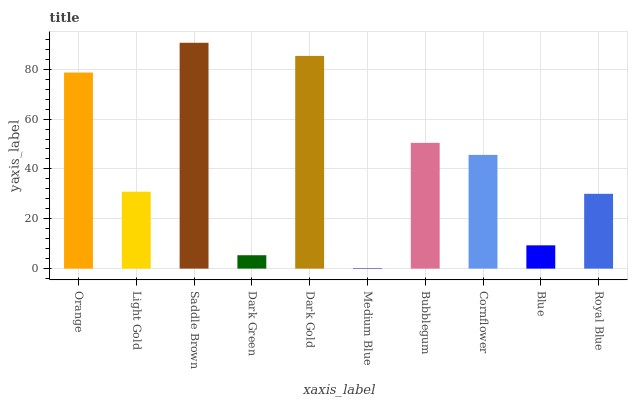Is Medium Blue the minimum?
Answer yes or no. Yes. Is Saddle Brown the maximum?
Answer yes or no. Yes. Is Light Gold the minimum?
Answer yes or no. No. Is Light Gold the maximum?
Answer yes or no. No. Is Orange greater than Light Gold?
Answer yes or no. Yes. Is Light Gold less than Orange?
Answer yes or no. Yes. Is Light Gold greater than Orange?
Answer yes or no. No. Is Orange less than Light Gold?
Answer yes or no. No. Is Cornflower the high median?
Answer yes or no. Yes. Is Light Gold the low median?
Answer yes or no. Yes. Is Blue the high median?
Answer yes or no. No. Is Cornflower the low median?
Answer yes or no. No. 